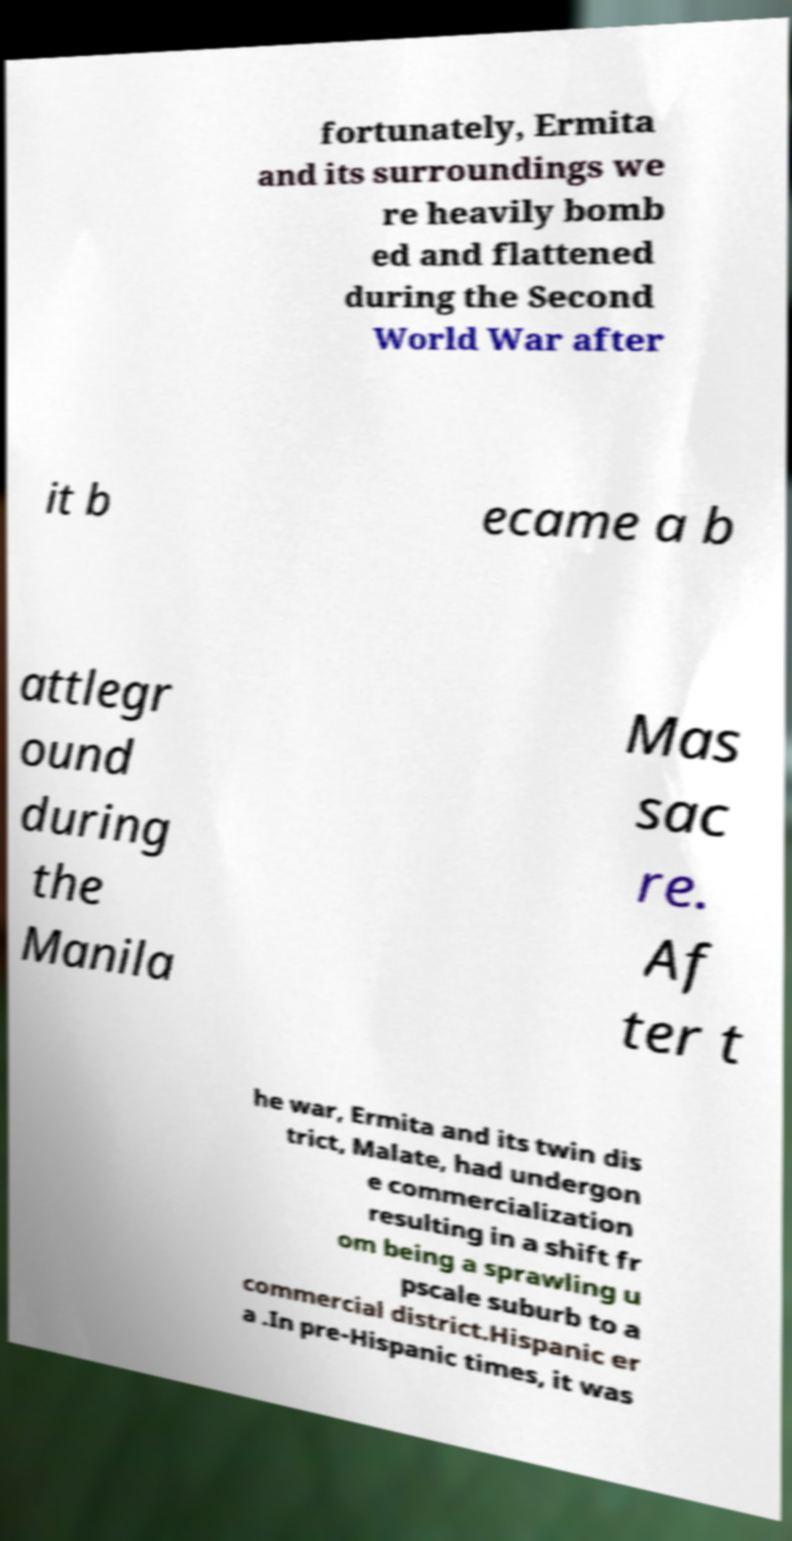There's text embedded in this image that I need extracted. Can you transcribe it verbatim? fortunately, Ermita and its surroundings we re heavily bomb ed and flattened during the Second World War after it b ecame a b attlegr ound during the Manila Mas sac re. Af ter t he war, Ermita and its twin dis trict, Malate, had undergon e commercialization resulting in a shift fr om being a sprawling u pscale suburb to a commercial district.Hispanic er a .In pre-Hispanic times, it was 